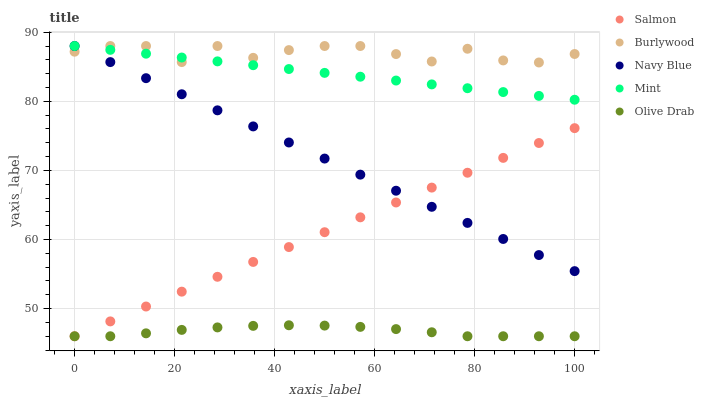Does Olive Drab have the minimum area under the curve?
Answer yes or no. Yes. Does Burlywood have the maximum area under the curve?
Answer yes or no. Yes. Does Navy Blue have the minimum area under the curve?
Answer yes or no. No. Does Navy Blue have the maximum area under the curve?
Answer yes or no. No. Is Mint the smoothest?
Answer yes or no. Yes. Is Burlywood the roughest?
Answer yes or no. Yes. Is Navy Blue the smoothest?
Answer yes or no. No. Is Navy Blue the roughest?
Answer yes or no. No. Does Salmon have the lowest value?
Answer yes or no. Yes. Does Navy Blue have the lowest value?
Answer yes or no. No. Does Mint have the highest value?
Answer yes or no. Yes. Does Salmon have the highest value?
Answer yes or no. No. Is Olive Drab less than Burlywood?
Answer yes or no. Yes. Is Burlywood greater than Salmon?
Answer yes or no. Yes. Does Olive Drab intersect Salmon?
Answer yes or no. Yes. Is Olive Drab less than Salmon?
Answer yes or no. No. Is Olive Drab greater than Salmon?
Answer yes or no. No. Does Olive Drab intersect Burlywood?
Answer yes or no. No. 